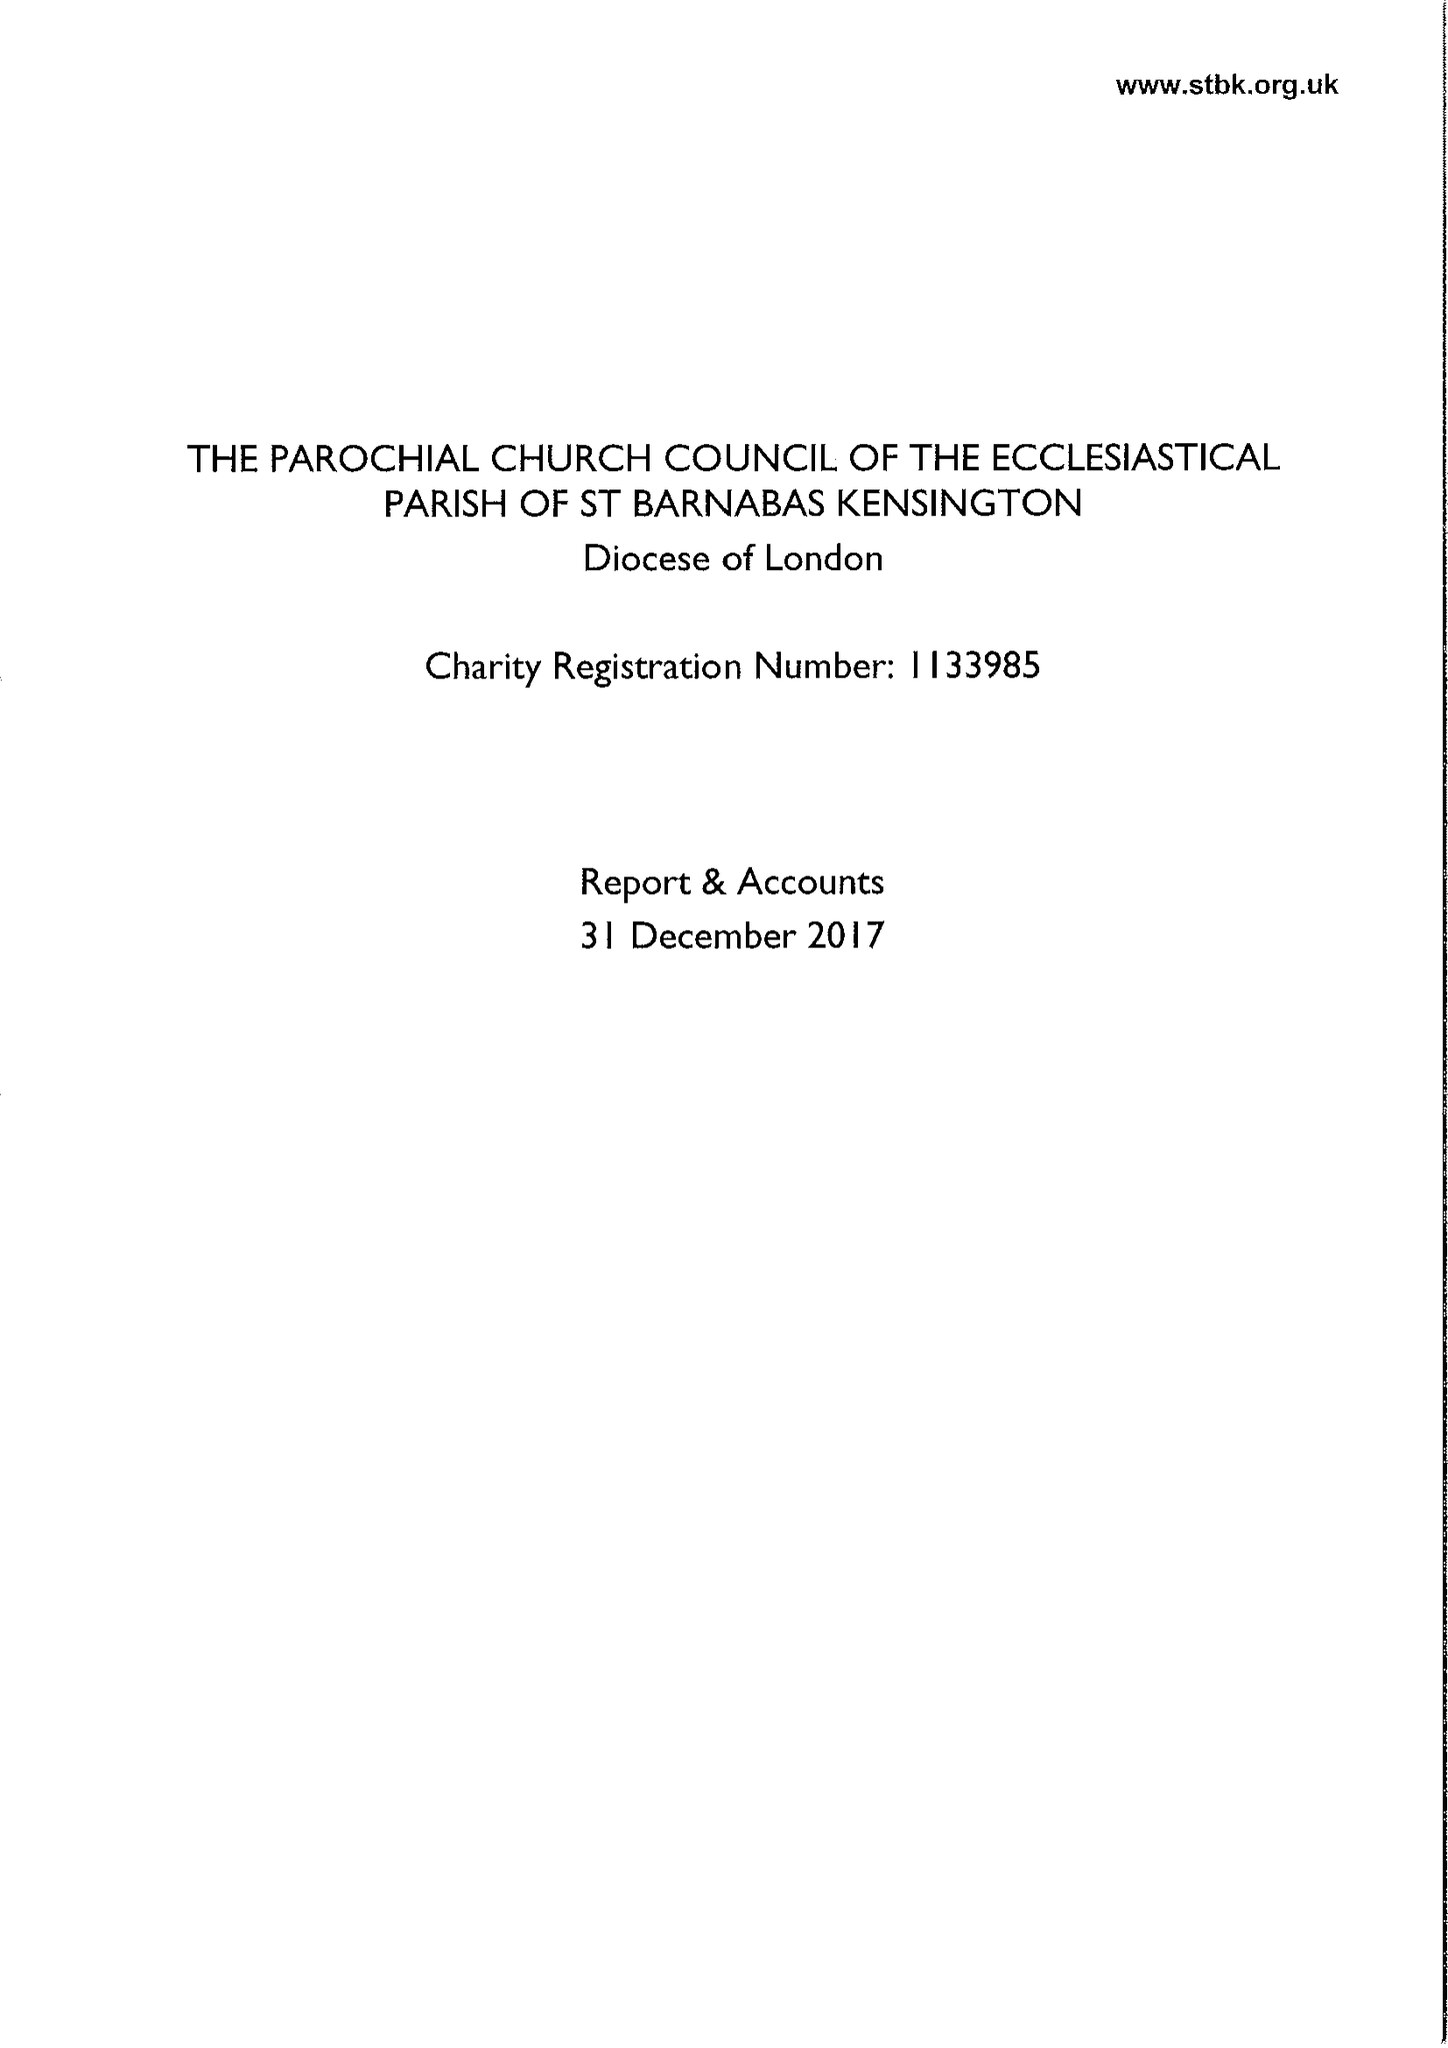What is the value for the report_date?
Answer the question using a single word or phrase. 2017-12-31 